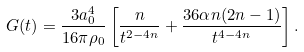Convert formula to latex. <formula><loc_0><loc_0><loc_500><loc_500>G ( t ) = \frac { 3 a _ { 0 } ^ { 4 } } { 1 6 \pi \rho _ { 0 } } \left [ \frac { n } { t ^ { 2 - 4 n } } + \frac { 3 6 \alpha n ( 2 n - 1 ) } { t ^ { 4 - 4 n } } \right ] .</formula> 